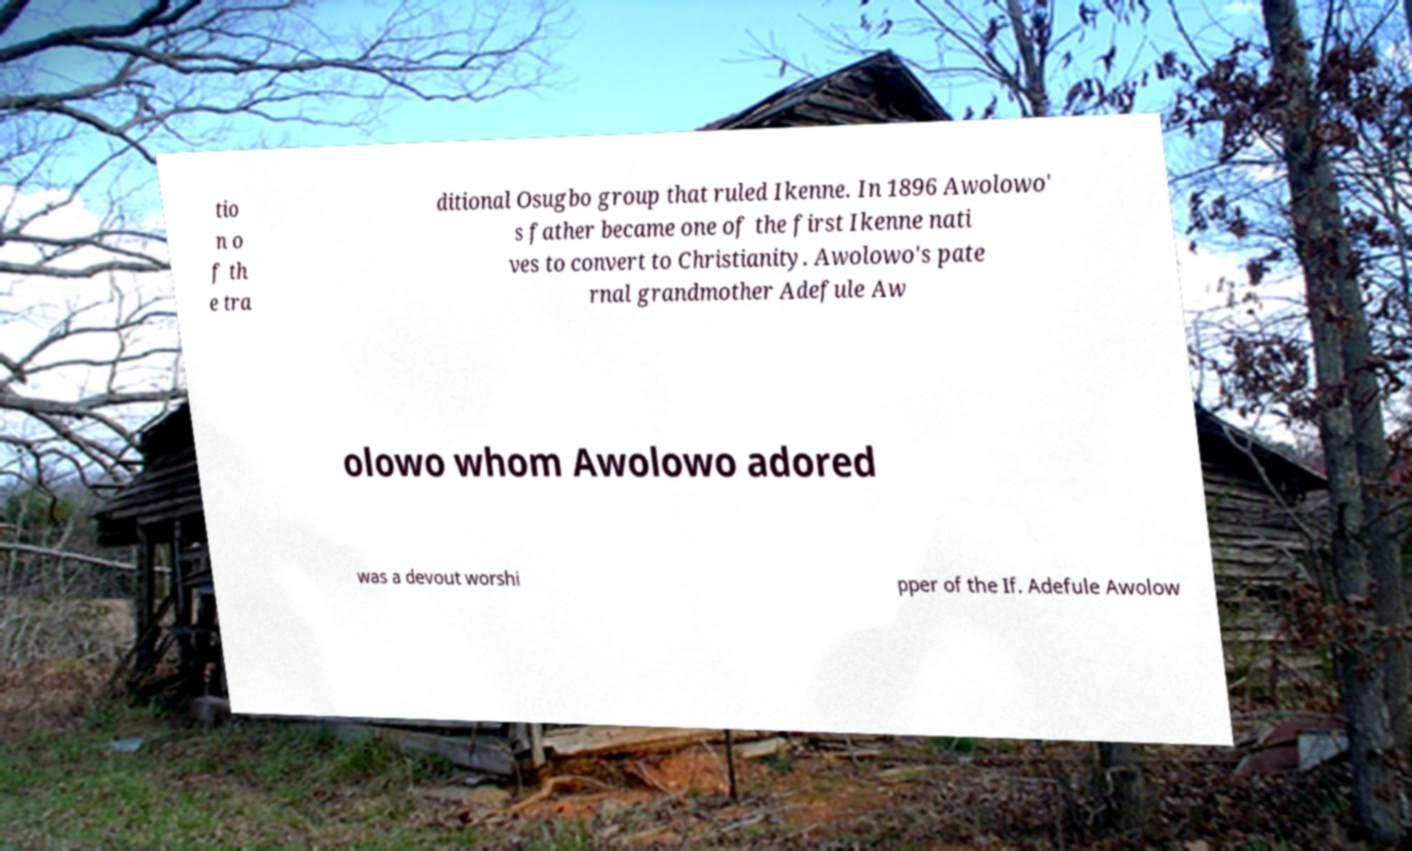Could you extract and type out the text from this image? tio n o f th e tra ditional Osugbo group that ruled Ikenne. In 1896 Awolowo' s father became one of the first Ikenne nati ves to convert to Christianity. Awolowo's pate rnal grandmother Adefule Aw olowo whom Awolowo adored was a devout worshi pper of the If. Adefule Awolow 